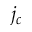<formula> <loc_0><loc_0><loc_500><loc_500>j _ { c }</formula> 